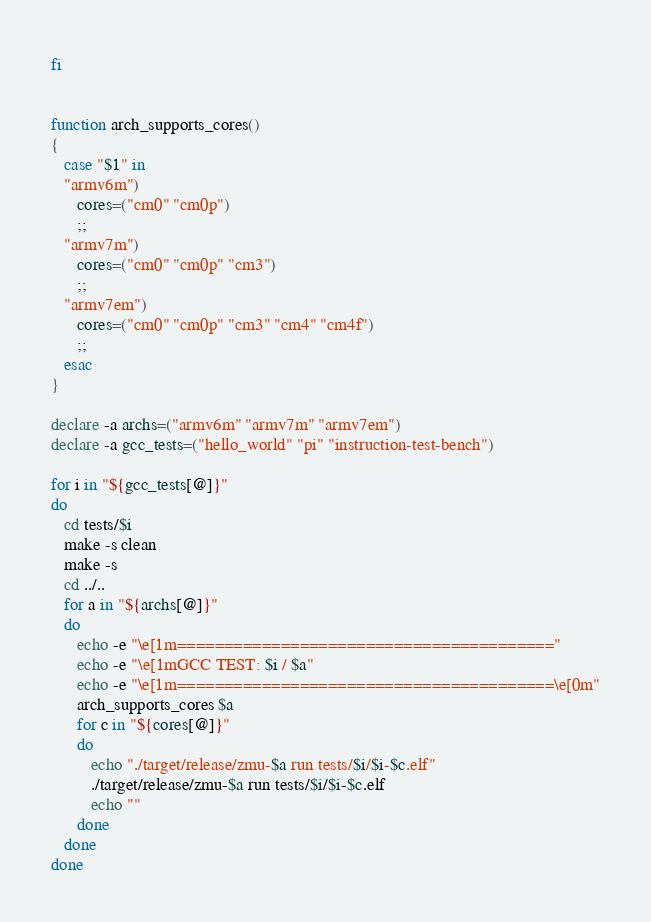Convert code to text. <code><loc_0><loc_0><loc_500><loc_500><_Bash_>fi


function arch_supports_cores()
{
   case "$1" in
   "armv6m") 
      cores=("cm0" "cm0p")
      ;;
   "armv7m") 
      cores=("cm0" "cm0p" "cm3")
      ;;
   "armv7em") 
      cores=("cm0" "cm0p" "cm3" "cm4" "cm4f")
      ;;
   esac
}

declare -a archs=("armv6m" "armv7m" "armv7em")
declare -a gcc_tests=("hello_world" "pi" "instruction-test-bench")

for i in "${gcc_tests[@]}"
do
   cd tests/$i
   make -s clean
   make -s
   cd ../..
   for a in "${archs[@]}"
   do
      echo -e "\e[1m========================================"
      echo -e "\e[1mGCC TEST: $i / $a"
      echo -e "\e[1m========================================\e[0m"
      arch_supports_cores $a
      for c in "${cores[@]}"
      do
         echo "./target/release/zmu-$a run tests/$i/$i-$c.elf"
         ./target/release/zmu-$a run tests/$i/$i-$c.elf
         echo ""
      done
   done
done
</code> 